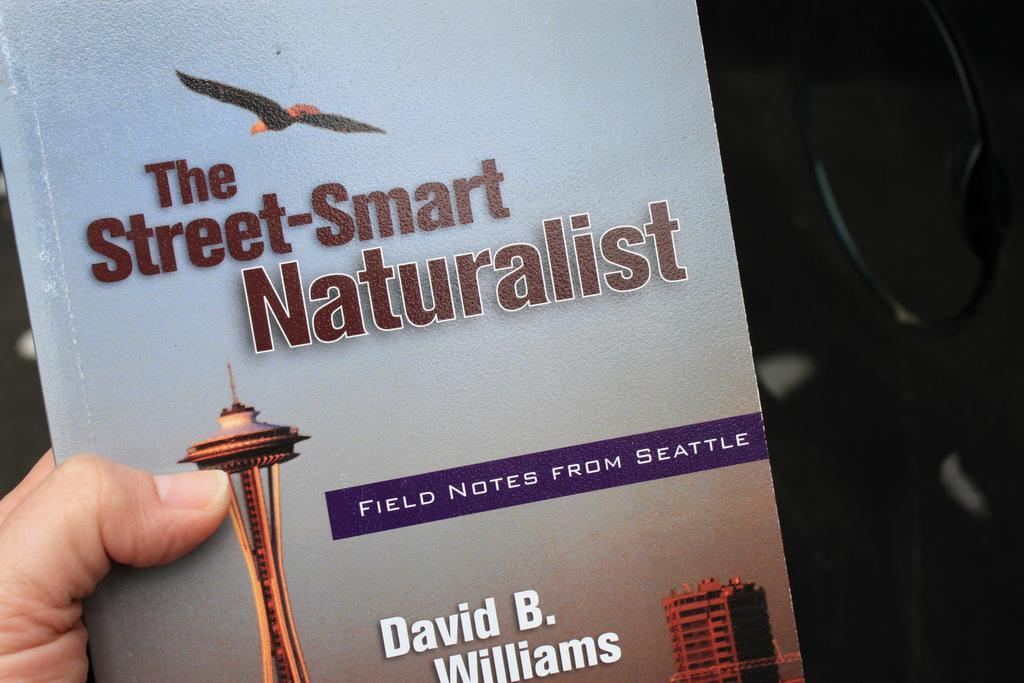<image>
Create a compact narrative representing the image presented. book called the street smart naturalist by david b williams 